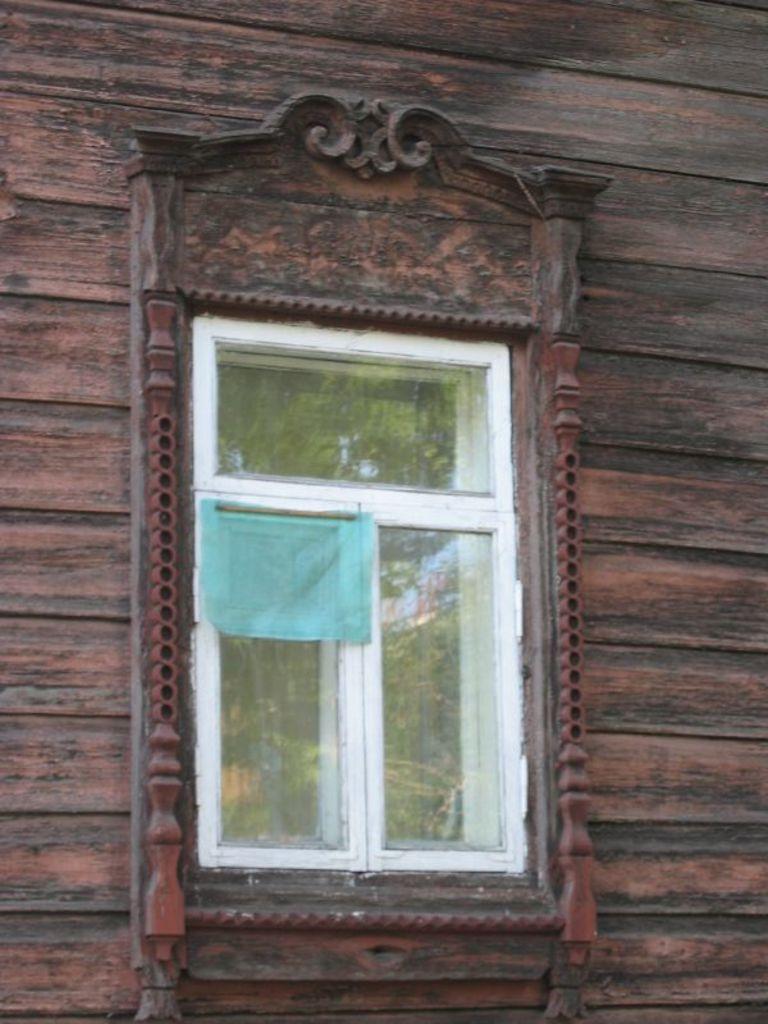In one or two sentences, can you explain what this image depicts? In this picture we can see a wall, there is a glass window here. 